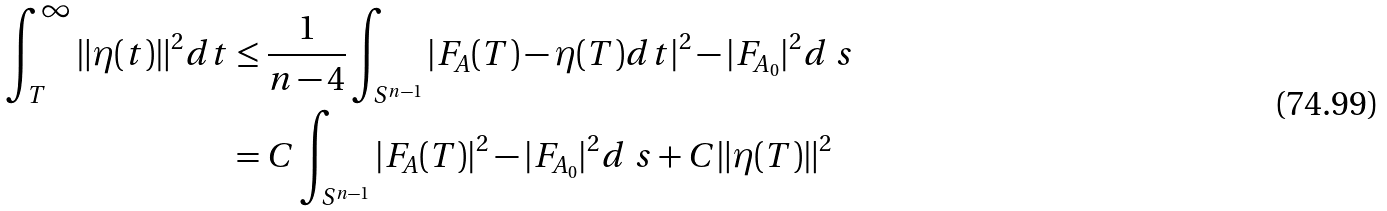Convert formula to latex. <formula><loc_0><loc_0><loc_500><loc_500>\int _ { T } ^ { \infty } \| \eta ( t ) \| ^ { 2 } d t & \leq \frac { 1 } { n - 4 } \int _ { S ^ { n - 1 } } | F _ { A } ( T ) - \eta ( T ) d t | ^ { 2 } - | F _ { A _ { 0 } } | ^ { 2 } d \ s \\ & = C \int _ { S ^ { n - 1 } } | F _ { A } ( T ) | ^ { 2 } - | F _ { A _ { 0 } } | ^ { 2 } d \ s + C \| \eta ( T ) \| ^ { 2 }</formula> 